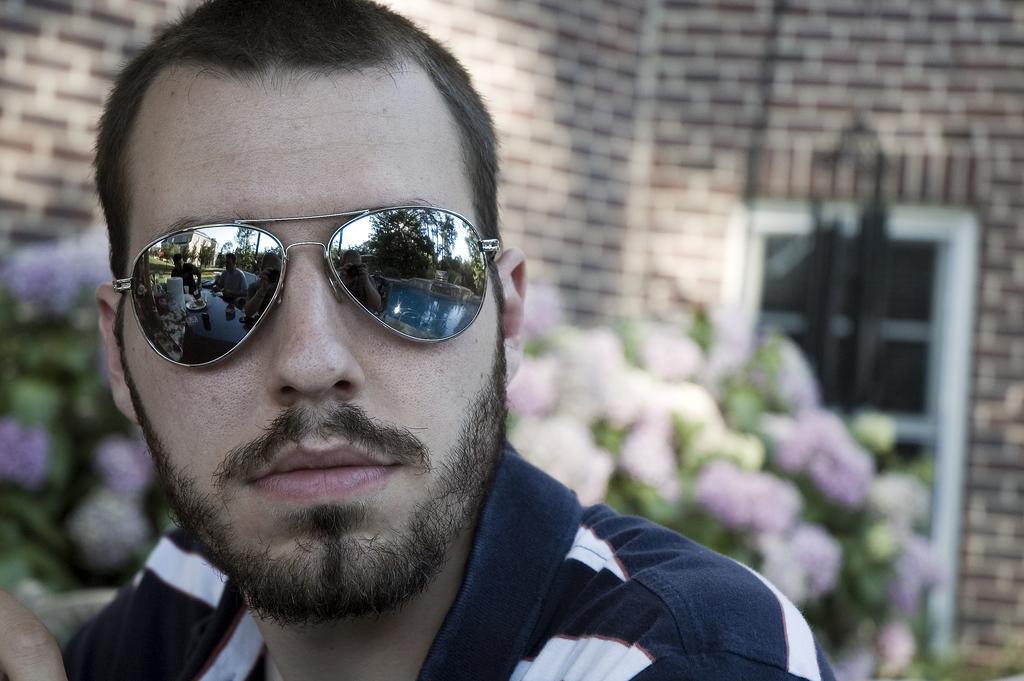Describe this image in one or two sentences. In this picture we can see a person, he is wearing a goggles and in the background we can see a wall, plants with flowers, doors, here we can see people, trees, sky, water and some objects. 